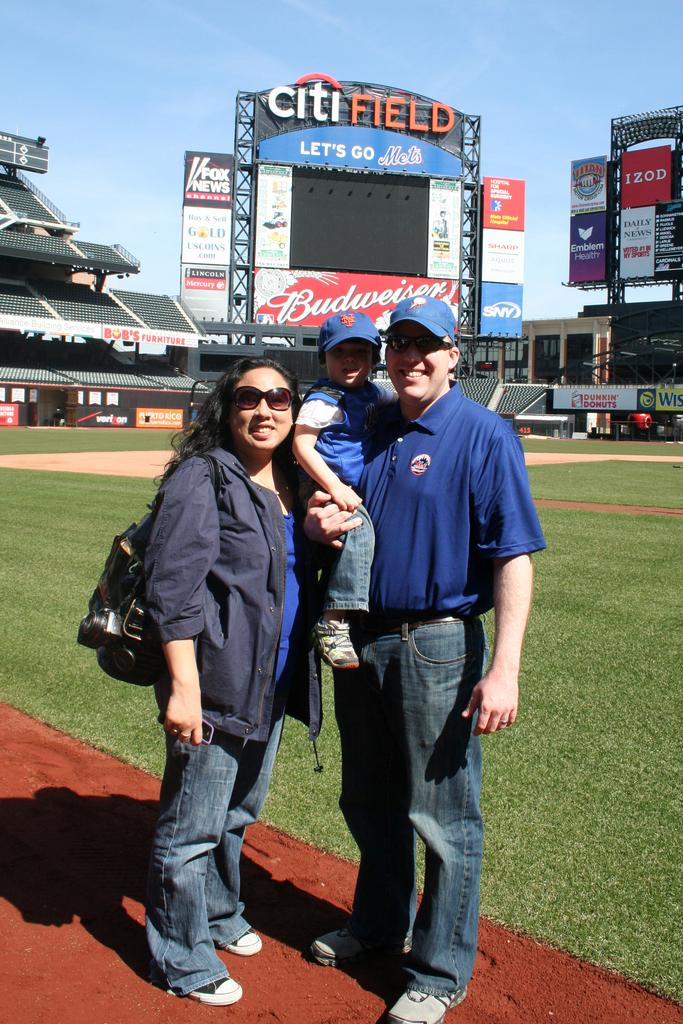<image>
Describe the image concisely. A couple and a child stand on the Citifield baseball field. 